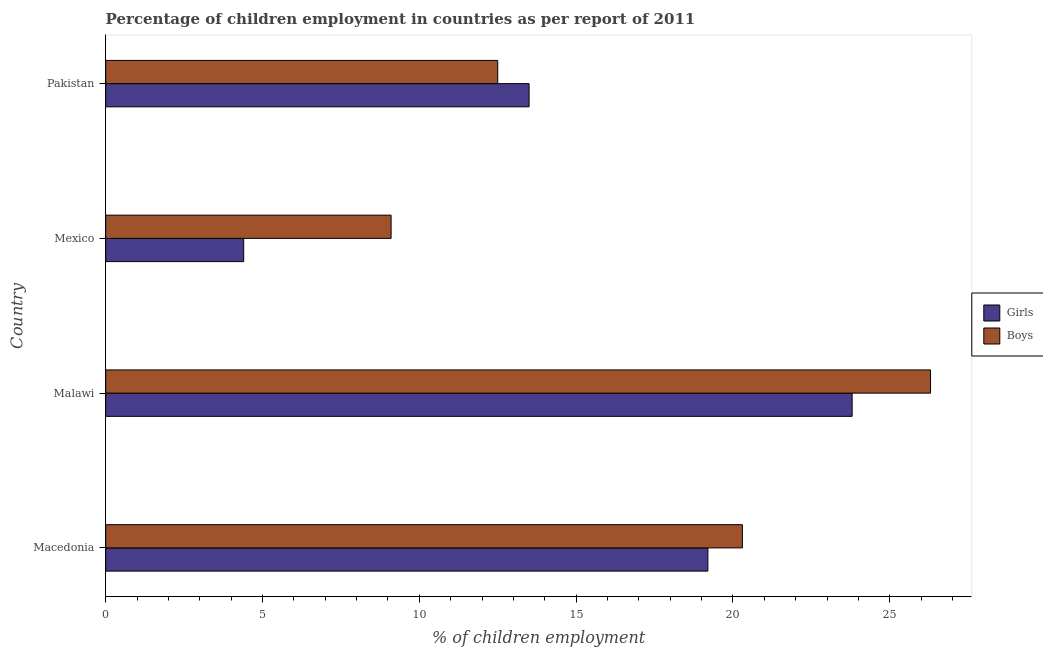How many groups of bars are there?
Your answer should be compact. 4. Are the number of bars per tick equal to the number of legend labels?
Your answer should be compact. Yes. How many bars are there on the 3rd tick from the top?
Keep it short and to the point. 2. How many bars are there on the 1st tick from the bottom?
Your response must be concise. 2. What is the percentage of employed girls in Malawi?
Keep it short and to the point. 23.8. Across all countries, what is the maximum percentage of employed boys?
Give a very brief answer. 26.3. In which country was the percentage of employed girls maximum?
Offer a very short reply. Malawi. In which country was the percentage of employed girls minimum?
Keep it short and to the point. Mexico. What is the total percentage of employed boys in the graph?
Your answer should be very brief. 68.2. What is the difference between the percentage of employed boys in Mexico and the percentage of employed girls in Macedonia?
Provide a short and direct response. -10.1. What is the average percentage of employed girls per country?
Give a very brief answer. 15.22. What is the difference between the percentage of employed girls and percentage of employed boys in Mexico?
Give a very brief answer. -4.7. In how many countries, is the percentage of employed boys greater than 1 %?
Your answer should be compact. 4. What is the ratio of the percentage of employed girls in Macedonia to that in Malawi?
Keep it short and to the point. 0.81. Is the percentage of employed girls in Macedonia less than that in Pakistan?
Ensure brevity in your answer.  No. What is the difference between the highest and the second highest percentage of employed boys?
Provide a short and direct response. 6. What is the difference between the highest and the lowest percentage of employed boys?
Offer a very short reply. 17.2. Is the sum of the percentage of employed girls in Malawi and Mexico greater than the maximum percentage of employed boys across all countries?
Your answer should be compact. Yes. What does the 1st bar from the top in Malawi represents?
Keep it short and to the point. Boys. What does the 1st bar from the bottom in Malawi represents?
Ensure brevity in your answer.  Girls. How many bars are there?
Your answer should be very brief. 8. What is the difference between two consecutive major ticks on the X-axis?
Offer a very short reply. 5. Does the graph contain any zero values?
Your response must be concise. No. How many legend labels are there?
Your answer should be compact. 2. How are the legend labels stacked?
Provide a succinct answer. Vertical. What is the title of the graph?
Provide a succinct answer. Percentage of children employment in countries as per report of 2011. What is the label or title of the X-axis?
Ensure brevity in your answer.  % of children employment. What is the % of children employment in Girls in Macedonia?
Offer a terse response. 19.2. What is the % of children employment of Boys in Macedonia?
Your answer should be very brief. 20.3. What is the % of children employment in Girls in Malawi?
Offer a terse response. 23.8. What is the % of children employment in Boys in Malawi?
Give a very brief answer. 26.3. What is the % of children employment of Girls in Mexico?
Make the answer very short. 4.4. What is the % of children employment of Boys in Mexico?
Provide a succinct answer. 9.1. Across all countries, what is the maximum % of children employment of Girls?
Give a very brief answer. 23.8. Across all countries, what is the maximum % of children employment in Boys?
Ensure brevity in your answer.  26.3. Across all countries, what is the minimum % of children employment in Girls?
Keep it short and to the point. 4.4. What is the total % of children employment in Girls in the graph?
Offer a terse response. 60.9. What is the total % of children employment in Boys in the graph?
Offer a terse response. 68.2. What is the difference between the % of children employment in Girls in Macedonia and that in Malawi?
Ensure brevity in your answer.  -4.6. What is the difference between the % of children employment of Girls in Malawi and that in Mexico?
Give a very brief answer. 19.4. What is the difference between the % of children employment of Boys in Malawi and that in Mexico?
Offer a very short reply. 17.2. What is the difference between the % of children employment of Boys in Malawi and that in Pakistan?
Give a very brief answer. 13.8. What is the difference between the % of children employment of Boys in Mexico and that in Pakistan?
Provide a short and direct response. -3.4. What is the difference between the % of children employment of Girls in Macedonia and the % of children employment of Boys in Pakistan?
Offer a very short reply. 6.7. What is the difference between the % of children employment of Girls in Malawi and the % of children employment of Boys in Mexico?
Ensure brevity in your answer.  14.7. What is the difference between the % of children employment of Girls in Mexico and the % of children employment of Boys in Pakistan?
Provide a short and direct response. -8.1. What is the average % of children employment in Girls per country?
Your answer should be very brief. 15.22. What is the average % of children employment in Boys per country?
Provide a short and direct response. 17.05. What is the difference between the % of children employment of Girls and % of children employment of Boys in Macedonia?
Offer a very short reply. -1.1. What is the ratio of the % of children employment of Girls in Macedonia to that in Malawi?
Your response must be concise. 0.81. What is the ratio of the % of children employment of Boys in Macedonia to that in Malawi?
Make the answer very short. 0.77. What is the ratio of the % of children employment of Girls in Macedonia to that in Mexico?
Provide a succinct answer. 4.36. What is the ratio of the % of children employment of Boys in Macedonia to that in Mexico?
Give a very brief answer. 2.23. What is the ratio of the % of children employment in Girls in Macedonia to that in Pakistan?
Provide a short and direct response. 1.42. What is the ratio of the % of children employment of Boys in Macedonia to that in Pakistan?
Provide a short and direct response. 1.62. What is the ratio of the % of children employment of Girls in Malawi to that in Mexico?
Make the answer very short. 5.41. What is the ratio of the % of children employment of Boys in Malawi to that in Mexico?
Give a very brief answer. 2.89. What is the ratio of the % of children employment of Girls in Malawi to that in Pakistan?
Your response must be concise. 1.76. What is the ratio of the % of children employment in Boys in Malawi to that in Pakistan?
Provide a succinct answer. 2.1. What is the ratio of the % of children employment of Girls in Mexico to that in Pakistan?
Your answer should be very brief. 0.33. What is the ratio of the % of children employment of Boys in Mexico to that in Pakistan?
Keep it short and to the point. 0.73. What is the difference between the highest and the second highest % of children employment of Girls?
Make the answer very short. 4.6. What is the difference between the highest and the second highest % of children employment in Boys?
Your answer should be very brief. 6. 